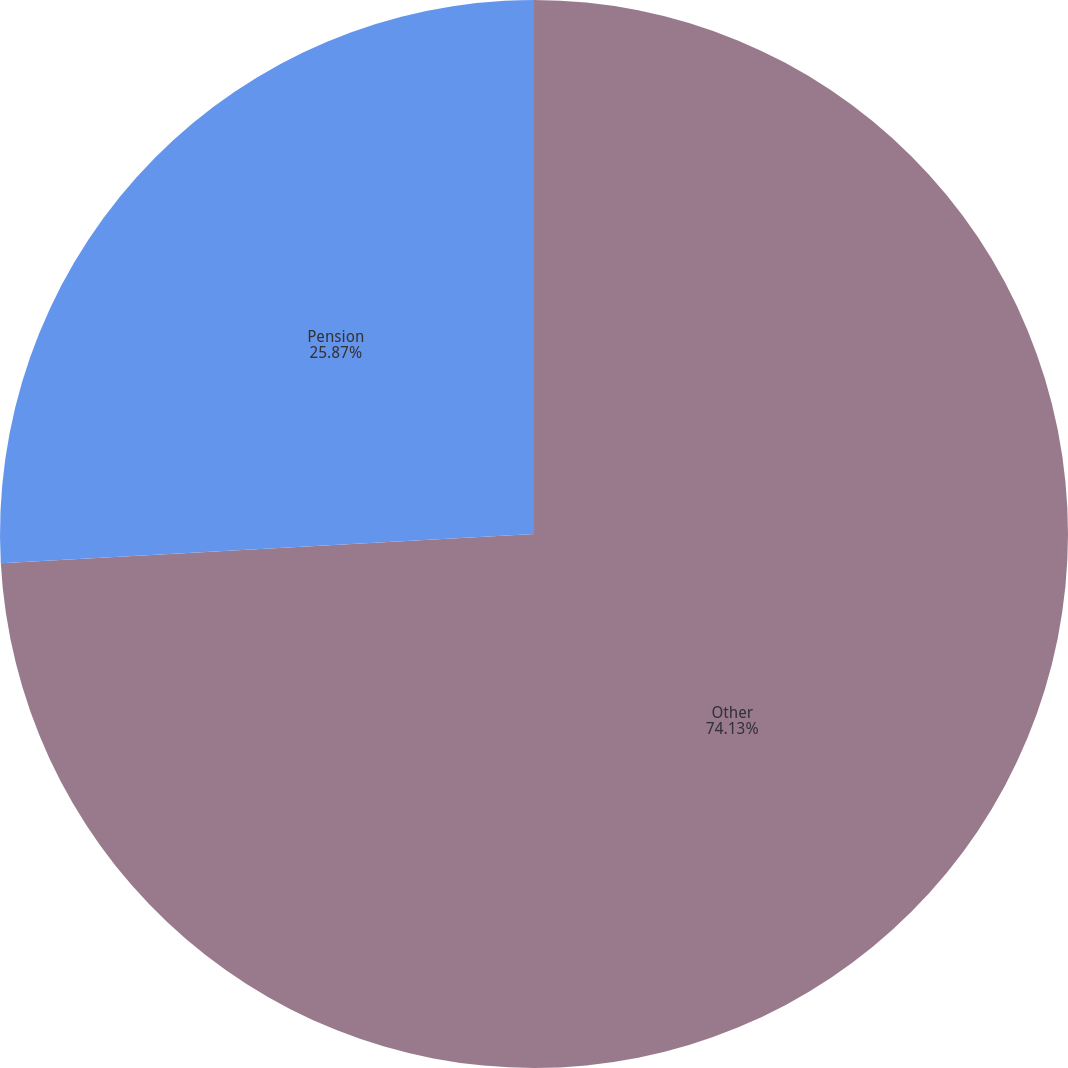Convert chart. <chart><loc_0><loc_0><loc_500><loc_500><pie_chart><fcel>Other<fcel>Pension<nl><fcel>74.13%<fcel>25.87%<nl></chart> 